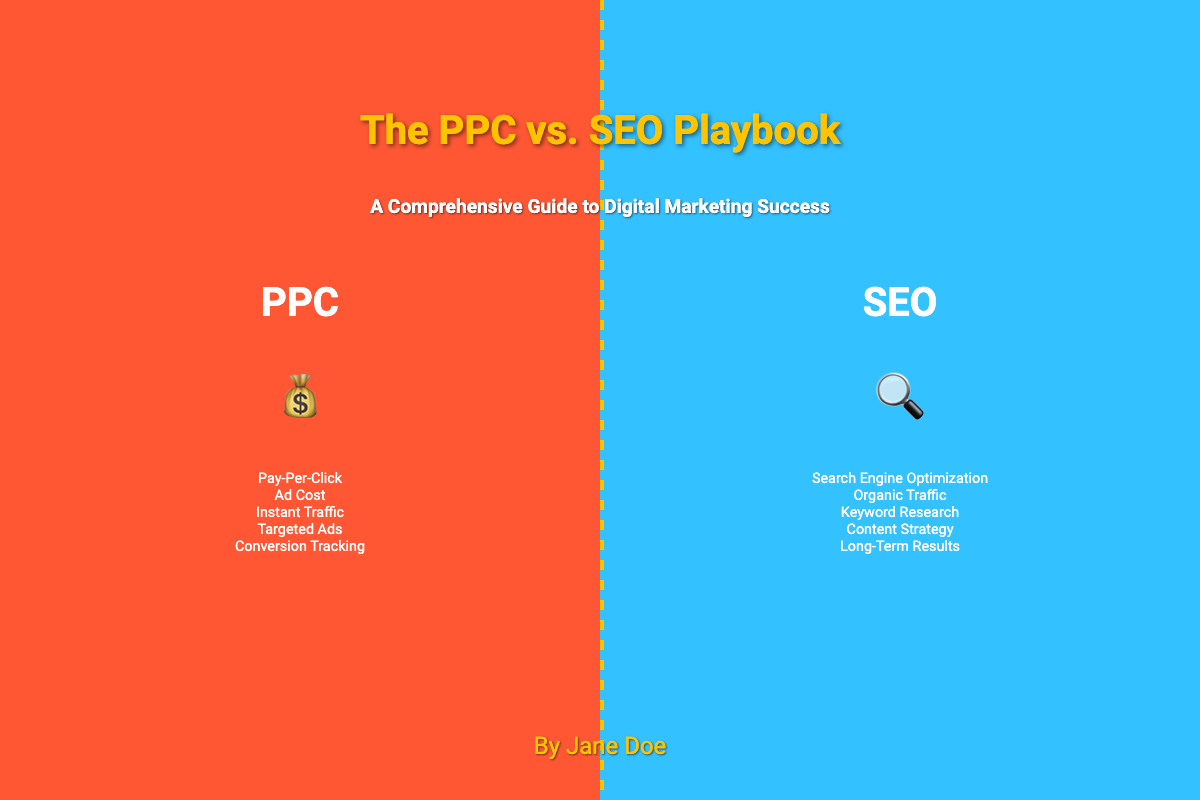What is the title of the book? The title of the book is prominently displayed in the center of the cover.
Answer: The PPC vs. SEO Playbook Who is the author? The author's name is listed at the bottom of the book cover.
Answer: Jane Doe What are the two main topics featured on the cover? The cover shows a tug-of-war between two marketing strategies.
Answer: PPC and SEO What symbol represents PPC? An icon is used to visually represent PPC on the cover.
Answer: 💰 What color represents SEO in the cover design? The color used to represent SEO on the left side of the cover is utilized in the background.
Answer: #33C1FF What is one characteristic of PPC mentioned on the cover? The cover includes specific keywords related to PPC's characteristics.
Answer: Instant Traffic What is the subtitle of the book? The subtitle provides additional context about the content of the book.
Answer: A Comprehensive Guide to Digital Marketing Success How many key features of SEO are listed on the cover? The cover contains a specific number of key features listed for the SEO section.
Answer: Five What does the central line on the cover signify? The central line visually separates the two distinct topics presented in the book.
Answer: Tug-of-war How is the title of the book styled? The title's presentation includes specific stylistic elements that enhance its visibility.
Answer: Bold and highlighted with a shadow 